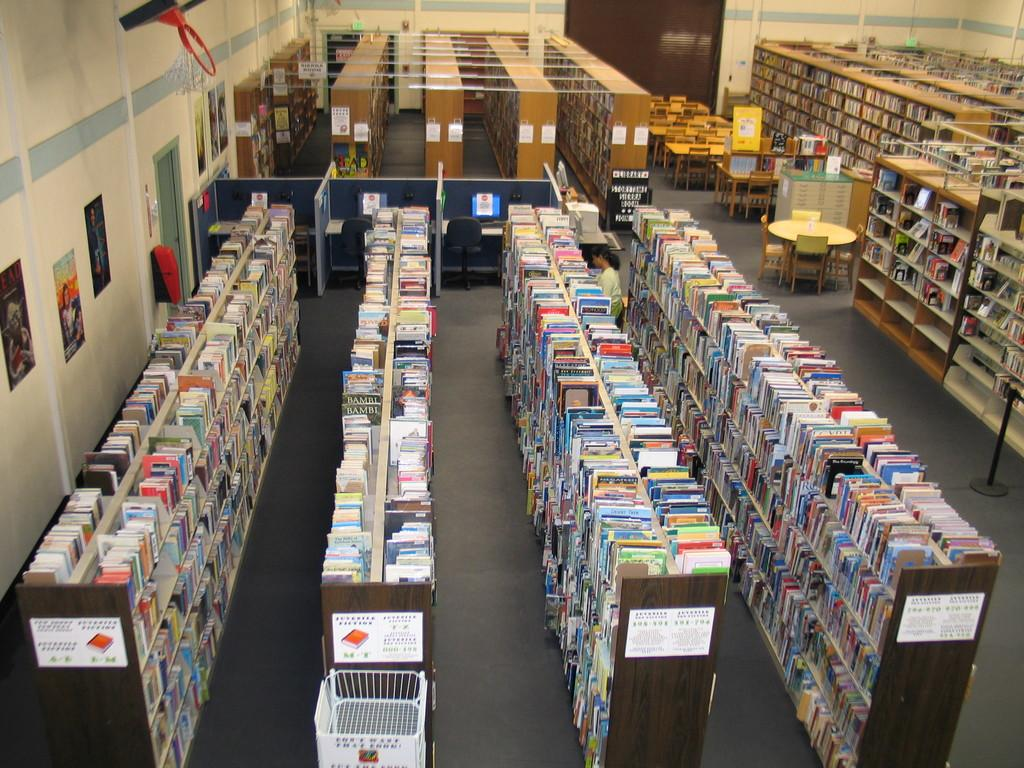What type of establishment is shown in the image? The image depicts a library. What can be found on the racks in the library? There are racks containing books in the library. What furniture is available for people to use in the library? There are tables and chairs in the library. Where are the tables and chairs located in relation to the wall? The tables and chairs are in front of a wall. Can you see your mom in the library? There is no indication of your mom being present in the image, as it only shows a library with book racks, tables, chairs, and a wall. 